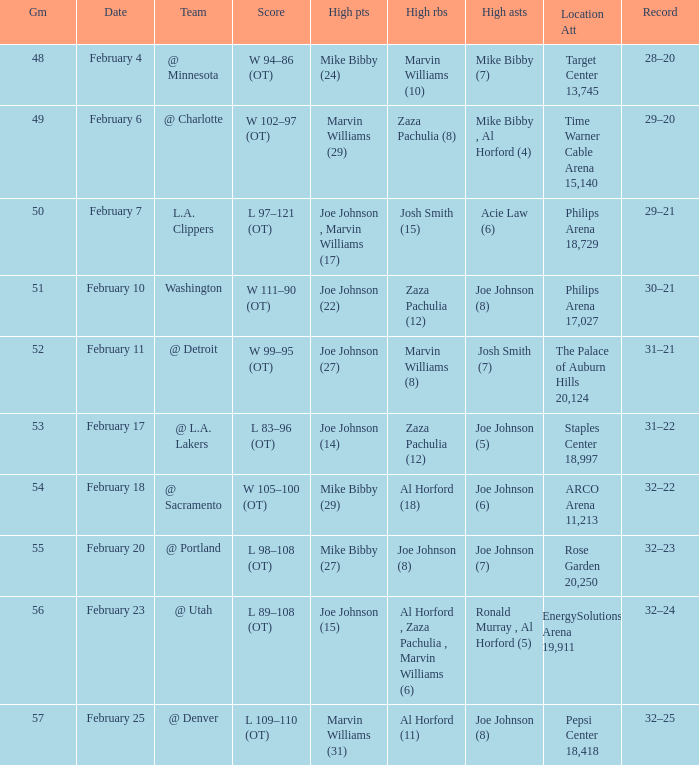How many high assists stats were maade on february 4 1.0. 